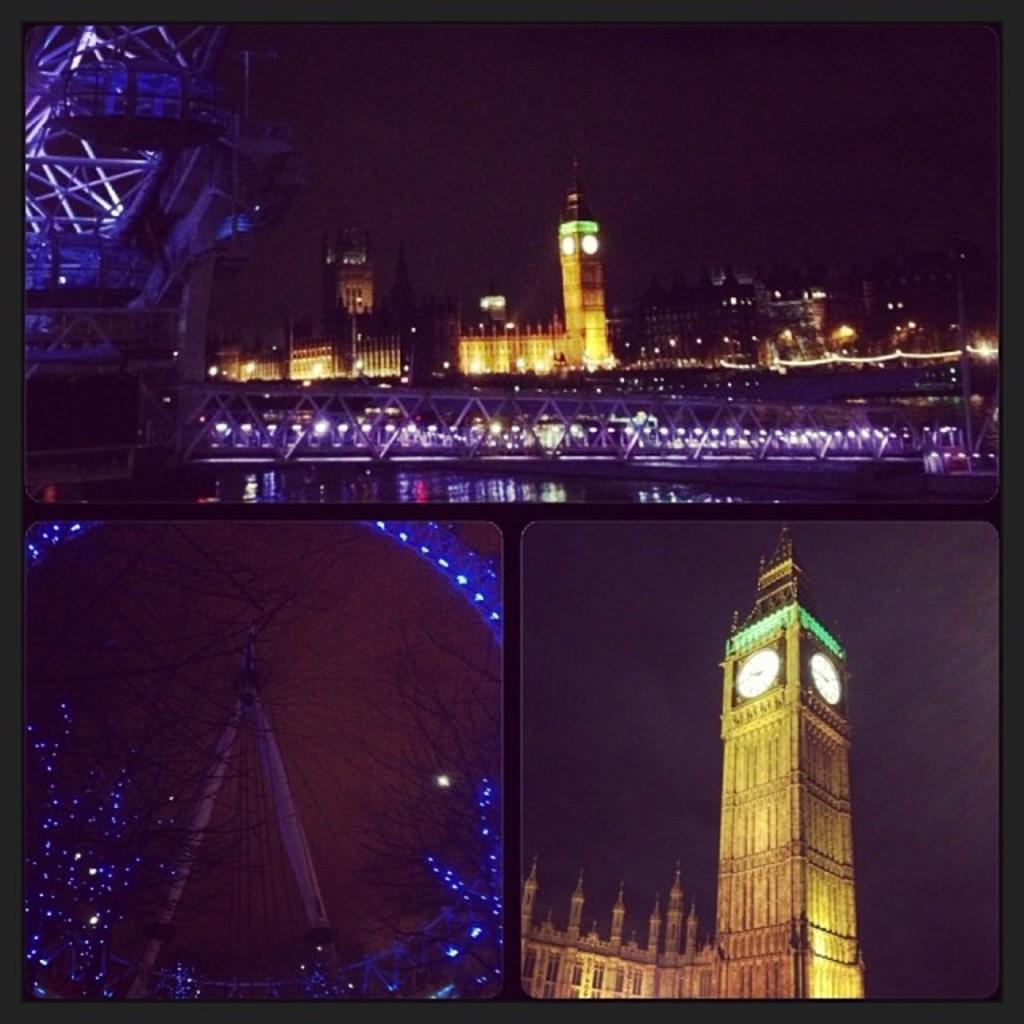Please provide a concise description of this image. This image is a collage image. There is a tower. There is a bridge. 